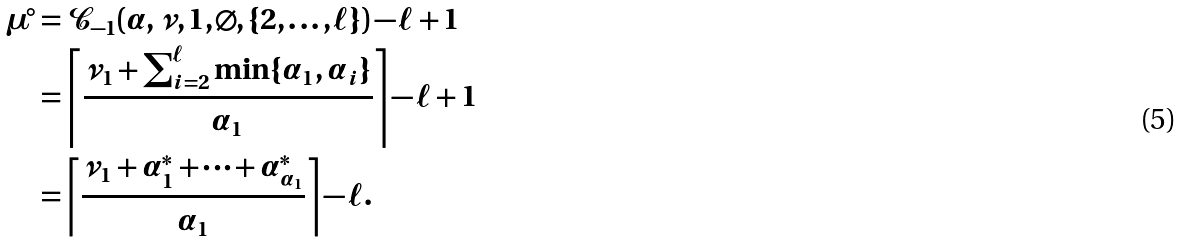<formula> <loc_0><loc_0><loc_500><loc_500>\mu ^ { \circ } & = \mathcal { C } _ { - 1 } ( \alpha , \nu , 1 , \varnothing , \{ 2 , \dots , \ell \} ) - \ell + 1 \\ & = \left \lceil \frac { \nu _ { 1 } + \sum _ { i = 2 } ^ { \ell } \min \{ \alpha _ { 1 } , \alpha _ { i } \} } { \alpha _ { 1 } } \right \rceil - \ell + 1 \\ & = \left \lceil \frac { \nu _ { 1 } + \alpha ^ { * } _ { 1 } + \cdots + \alpha ^ { * } _ { \alpha _ { 1 } } } { \alpha _ { 1 } } \right \rceil - \ell .</formula> 